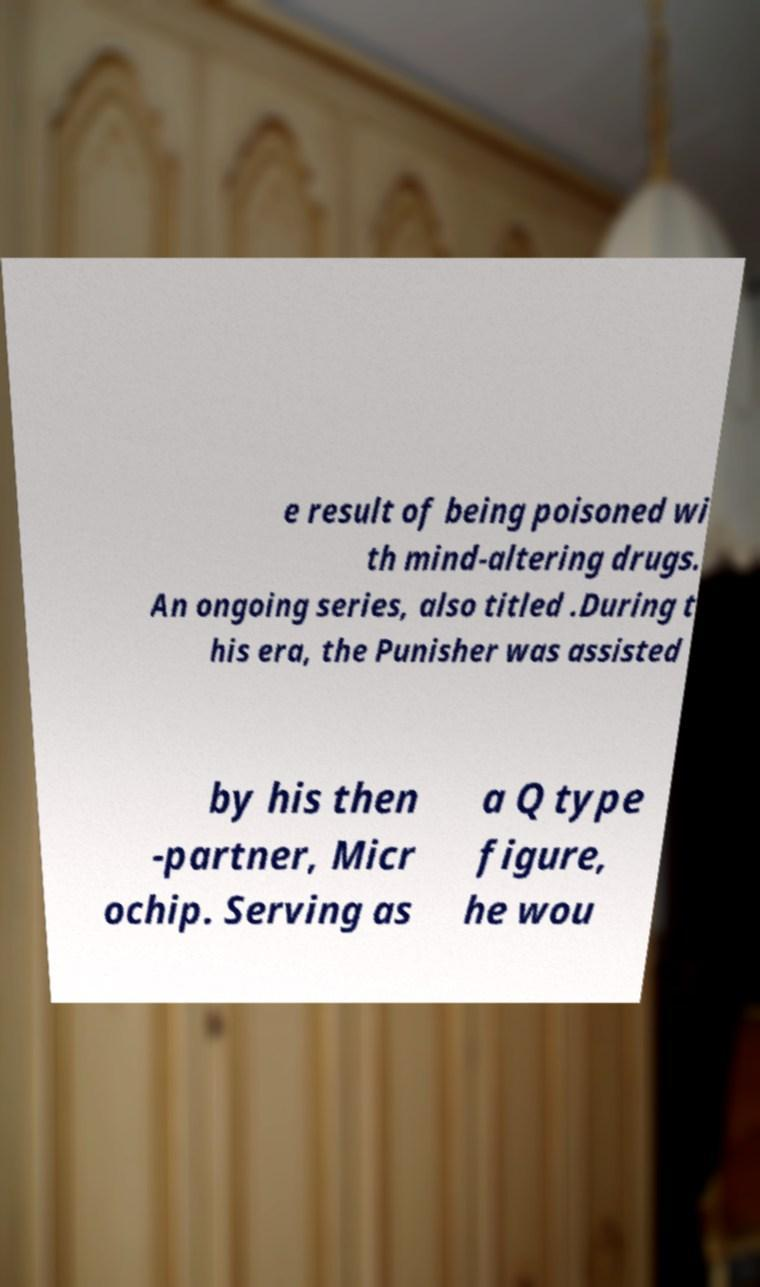What messages or text are displayed in this image? I need them in a readable, typed format. e result of being poisoned wi th mind-altering drugs. An ongoing series, also titled .During t his era, the Punisher was assisted by his then -partner, Micr ochip. Serving as a Q type figure, he wou 